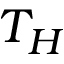Convert formula to latex. <formula><loc_0><loc_0><loc_500><loc_500>T _ { H }</formula> 